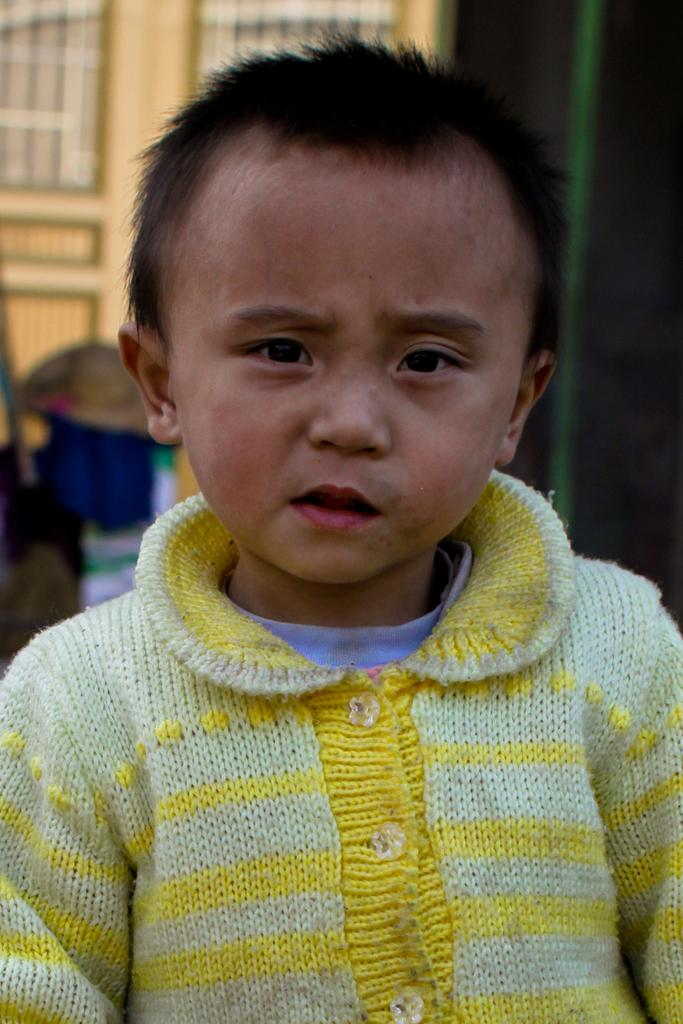What is the main subject of the image? There is a child in the image. What is the child doing in the image? The child is standing. Can you describe the background of the image? The background of the image is blurred. What observation can be made about the child's feelings in the image? There is no information about the child's feelings in the image, as it only shows the child standing with a blurred background. 